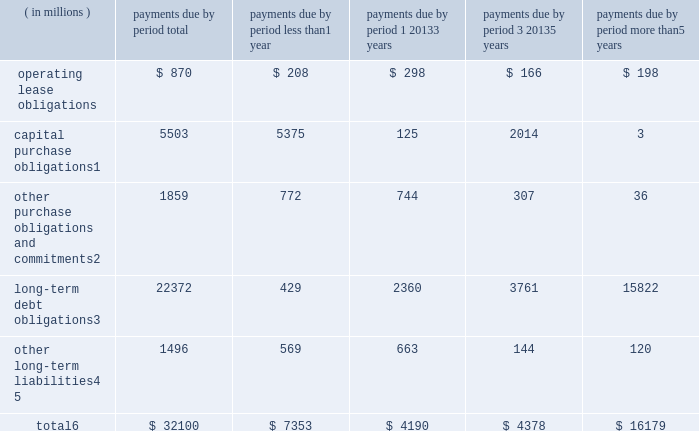Contractual obligations the table summarizes our significant contractual obligations as of december 28 , 2013: .
Capital purchase obligations1 5503 5375 125 2014 3 other purchase obligations and commitments2 1859 772 744 307 36 long-term debt obligations3 22372 429 2360 3761 15822 other long-term liabilities4 , 5 1496 569 663 144 120 total6 $ 32100 $ 7353 $ 4190 $ 4378 $ 16179 1 capital purchase obligations represent commitments for the construction or purchase of property , plant and equipment .
They were not recorded as liabilities on our consolidated balance sheets as of december 28 , 2013 , as we had not yet received the related goods or taken title to the property .
2 other purchase obligations and commitments include payments due under various types of licenses and agreements to purchase goods or services , as well as payments due under non-contingent funding obligations .
Funding obligations include agreements to fund various projects with other companies .
3 amounts represent principal and interest cash payments over the life of the debt obligations , including anticipated interest payments that are not recorded on our consolidated balance sheets .
Any future settlement of convertible debt would impact our cash payments .
4 we are unable to reliably estimate the timing of future payments related to uncertain tax positions ; therefore , $ 188 million of long-term income taxes payable has been excluded from the preceding table .
However , long- term income taxes payable , recorded on our consolidated balance sheets , included these uncertain tax positions , reduced by the associated federal deduction for state taxes and u.s .
Tax credits arising from non- u.s .
Income taxes .
5 amounts represent future cash payments to satisfy other long-term liabilities recorded on our consolidated balance sheets , including the short-term portion of these long-term liabilities .
Expected required contributions to our u.s .
And non-u.s .
Pension plans and other postretirement benefit plans of $ 62 million to be made during 2014 are also included ; however , funding projections beyond 2014 are not practicable to estimate .
6 total excludes contractual obligations already recorded on our consolidated balance sheets as current liabilities except for the short-term portions of long-term debt obligations and other long-term liabilities .
Contractual obligations for purchases of goods or services , included in other purchase obligations and commitments in the preceding table , include agreements that are enforceable and legally binding on intel and that specify all significant terms , including fixed or minimum quantities to be purchased ; fixed , minimum , or variable price provisions ; and the approximate timing of the transaction .
For obligations with cancellation provisions , the amounts included in the preceding table were limited to the non-cancelable portion of the agreement terms or the minimum cancellation fee .
We have entered into certain agreements for the purchase of raw materials that specify minimum prices and quantities based on a percentage of the total available market or based on a percentage of our future purchasing requirements .
Due to the uncertainty of the future market and our future purchasing requirements , as well as the non-binding nature of these agreements , obligations under these agreements are not included in the preceding table .
Our purchase orders for other products are based on our current manufacturing needs and are fulfilled by our vendors within short time horizons .
In addition , some of our purchase orders represent authorizations to purchase rather than binding agreements .
Table of contents management 2019s discussion and analysis of financial condition and results of operations ( continued ) .
What percentage of total contractual obligations as of december 28 , 2013 is made up of capital purchase obligations? 
Computations: (5503 / 32100)
Answer: 0.17143. 